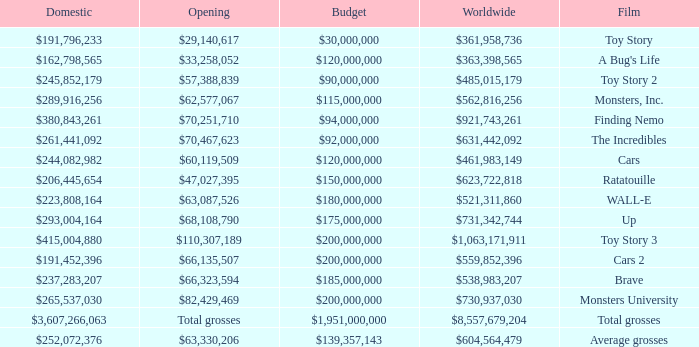WHAT IS THE BUDGET FOR THE INCREDIBLES? $92,000,000. 